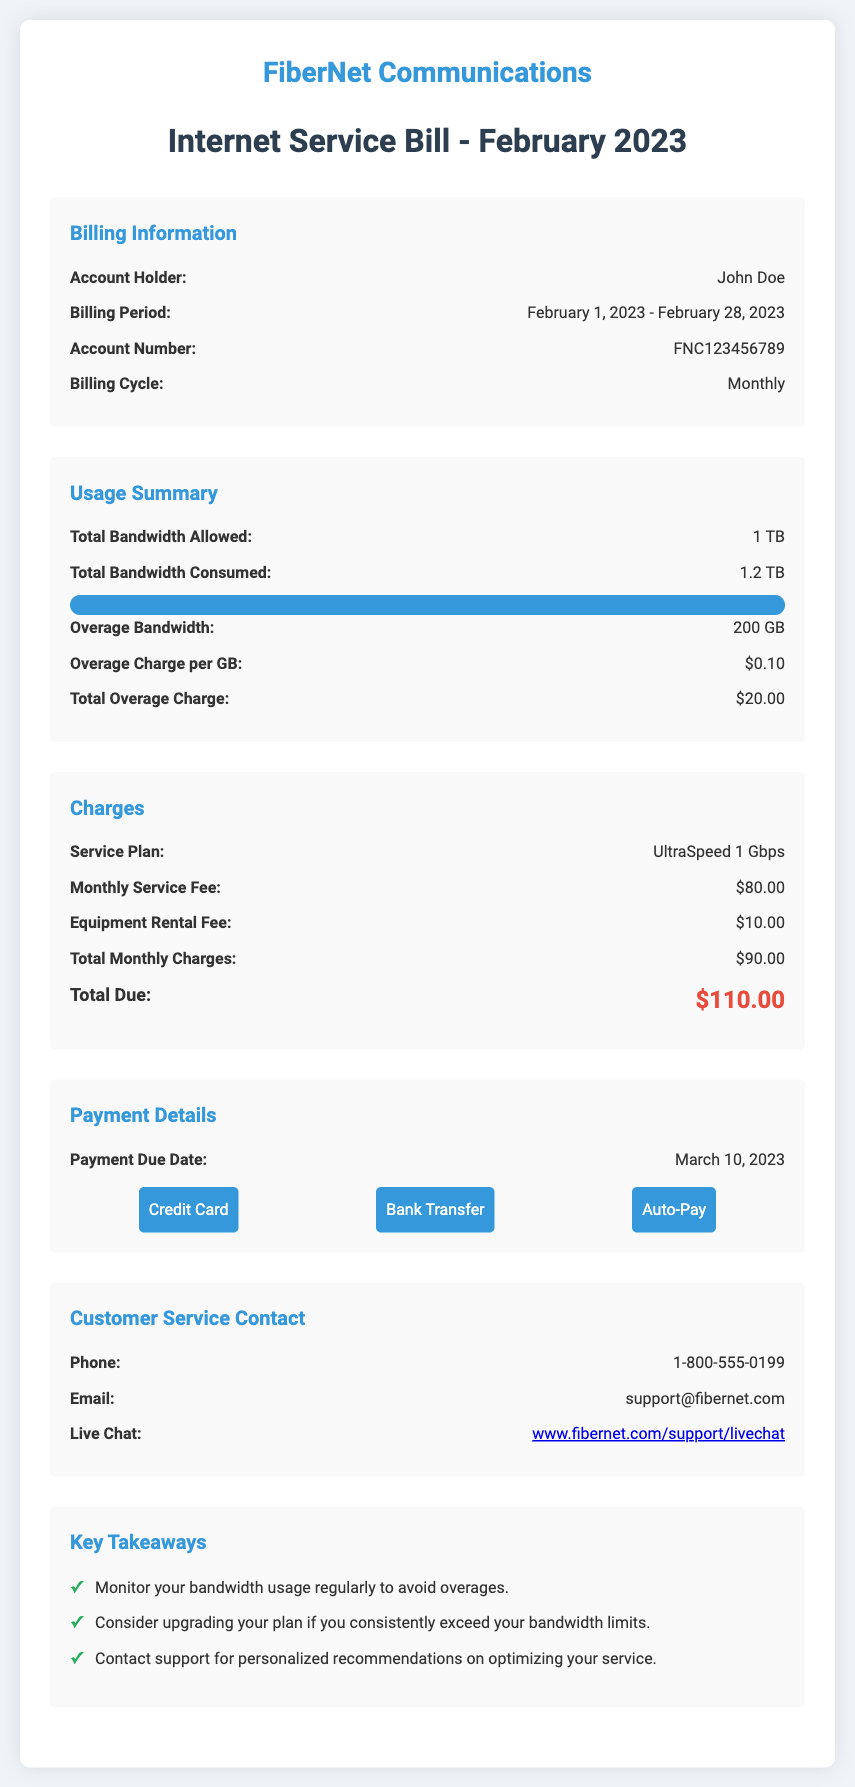What is the account holder's name? The account holder's name is stated in the billing information section.
Answer: John Doe What is the total bandwidth consumed? This information is found in the usage summary section.
Answer: 1.2 TB What is the overage charge per GB? The overage charge per GB is specified in the usage summary section.
Answer: $0.10 What is the monthly service fee? The monthly service fee is listed in the charges section.
Answer: $80.00 What is the total due for the month? The total due is found in the charges section, calculated from all charges.
Answer: $110.00 What is the payment due date? This detail is provided in the payment details section of the document.
Answer: March 10, 2023 How much overage bandwidth is used? The overage bandwidth used is indicated in the usage summary.
Answer: 200 GB What services can be used for payment? This information is found in the payment details section about payment methods.
Answer: Credit Card, Bank Transfer, Auto-Pay What is the equipment rental fee? The equipment rental fee is stated in the charges section.
Answer: $10.00 